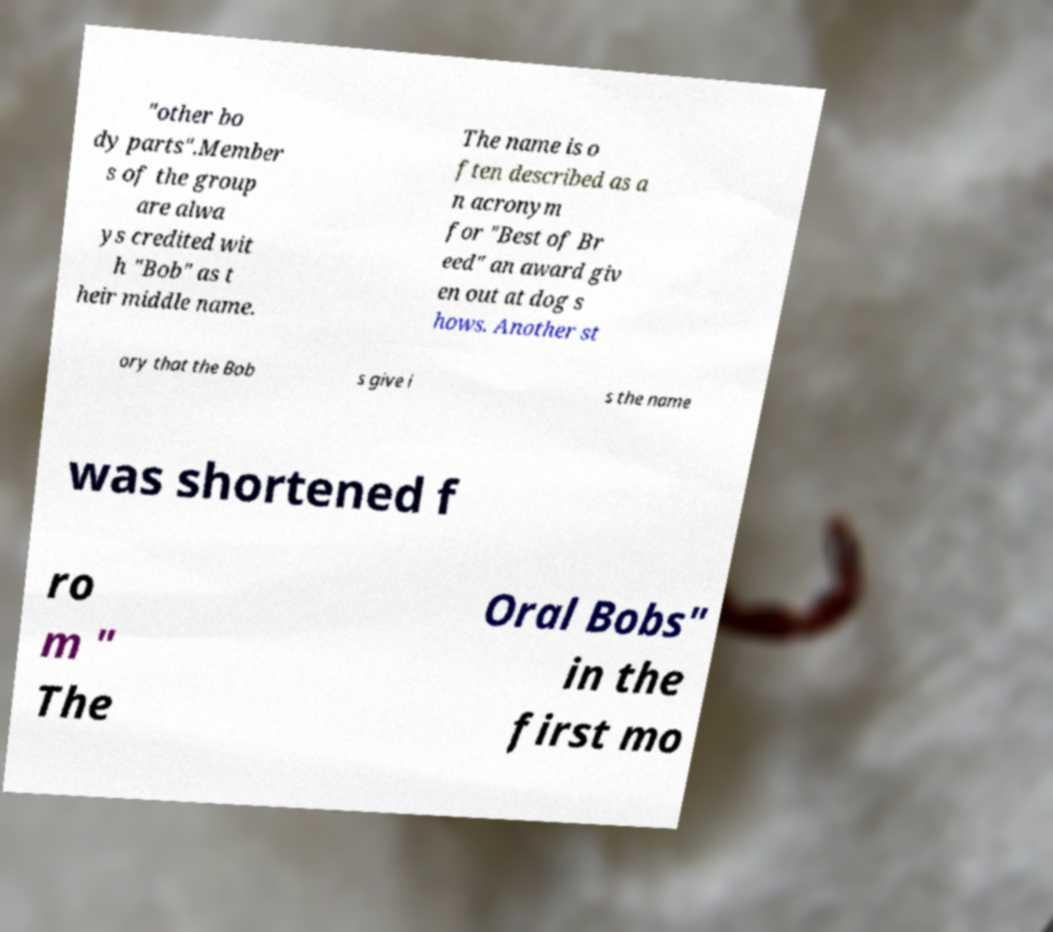Please read and relay the text visible in this image. What does it say? "other bo dy parts".Member s of the group are alwa ys credited wit h "Bob" as t heir middle name. The name is o ften described as a n acronym for "Best of Br eed" an award giv en out at dog s hows. Another st ory that the Bob s give i s the name was shortened f ro m " The Oral Bobs" in the first mo 